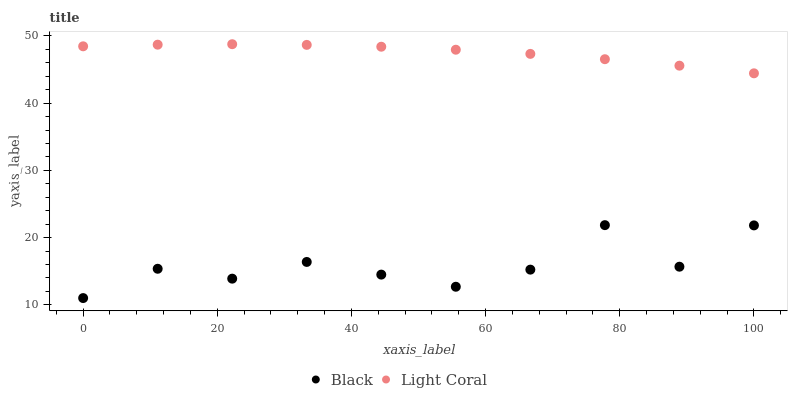Does Black have the minimum area under the curve?
Answer yes or no. Yes. Does Light Coral have the maximum area under the curve?
Answer yes or no. Yes. Does Black have the maximum area under the curve?
Answer yes or no. No. Is Light Coral the smoothest?
Answer yes or no. Yes. Is Black the roughest?
Answer yes or no. Yes. Is Black the smoothest?
Answer yes or no. No. Does Black have the lowest value?
Answer yes or no. Yes. Does Light Coral have the highest value?
Answer yes or no. Yes. Does Black have the highest value?
Answer yes or no. No. Is Black less than Light Coral?
Answer yes or no. Yes. Is Light Coral greater than Black?
Answer yes or no. Yes. Does Black intersect Light Coral?
Answer yes or no. No. 